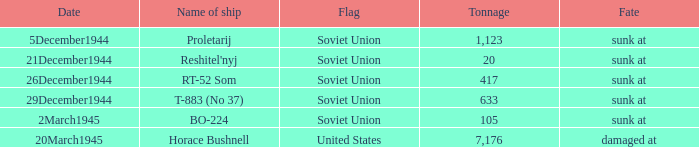What is the average tonnage of the ship named proletarij? 1123.0. Would you be able to parse every entry in this table? {'header': ['Date', 'Name of ship', 'Flag', 'Tonnage', 'Fate'], 'rows': [['5December1944', 'Proletarij', 'Soviet Union', '1,123', 'sunk at'], ['21December1944', "Reshitel'nyj", 'Soviet Union', '20', 'sunk at'], ['26December1944', 'RT-52 Som', 'Soviet Union', '417', 'sunk at'], ['29December1944', 'T-883 (No 37)', 'Soviet Union', '633', 'sunk at'], ['2March1945', 'BO-224', 'Soviet Union', '105', 'sunk at'], ['20March1945', 'Horace Bushnell', 'United States', '7,176', 'damaged at']]} 